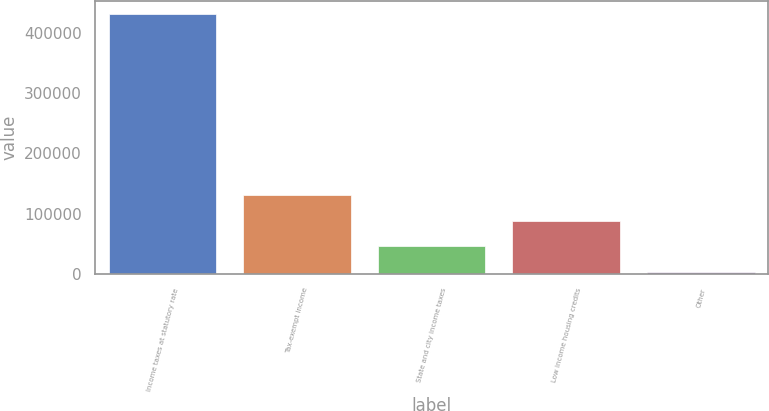<chart> <loc_0><loc_0><loc_500><loc_500><bar_chart><fcel>Income taxes at statutory rate<fcel>Tax-exempt income<fcel>State and city income taxes<fcel>Low income housing credits<fcel>Other<nl><fcel>431075<fcel>131451<fcel>45844.4<fcel>88647.8<fcel>3041<nl></chart> 